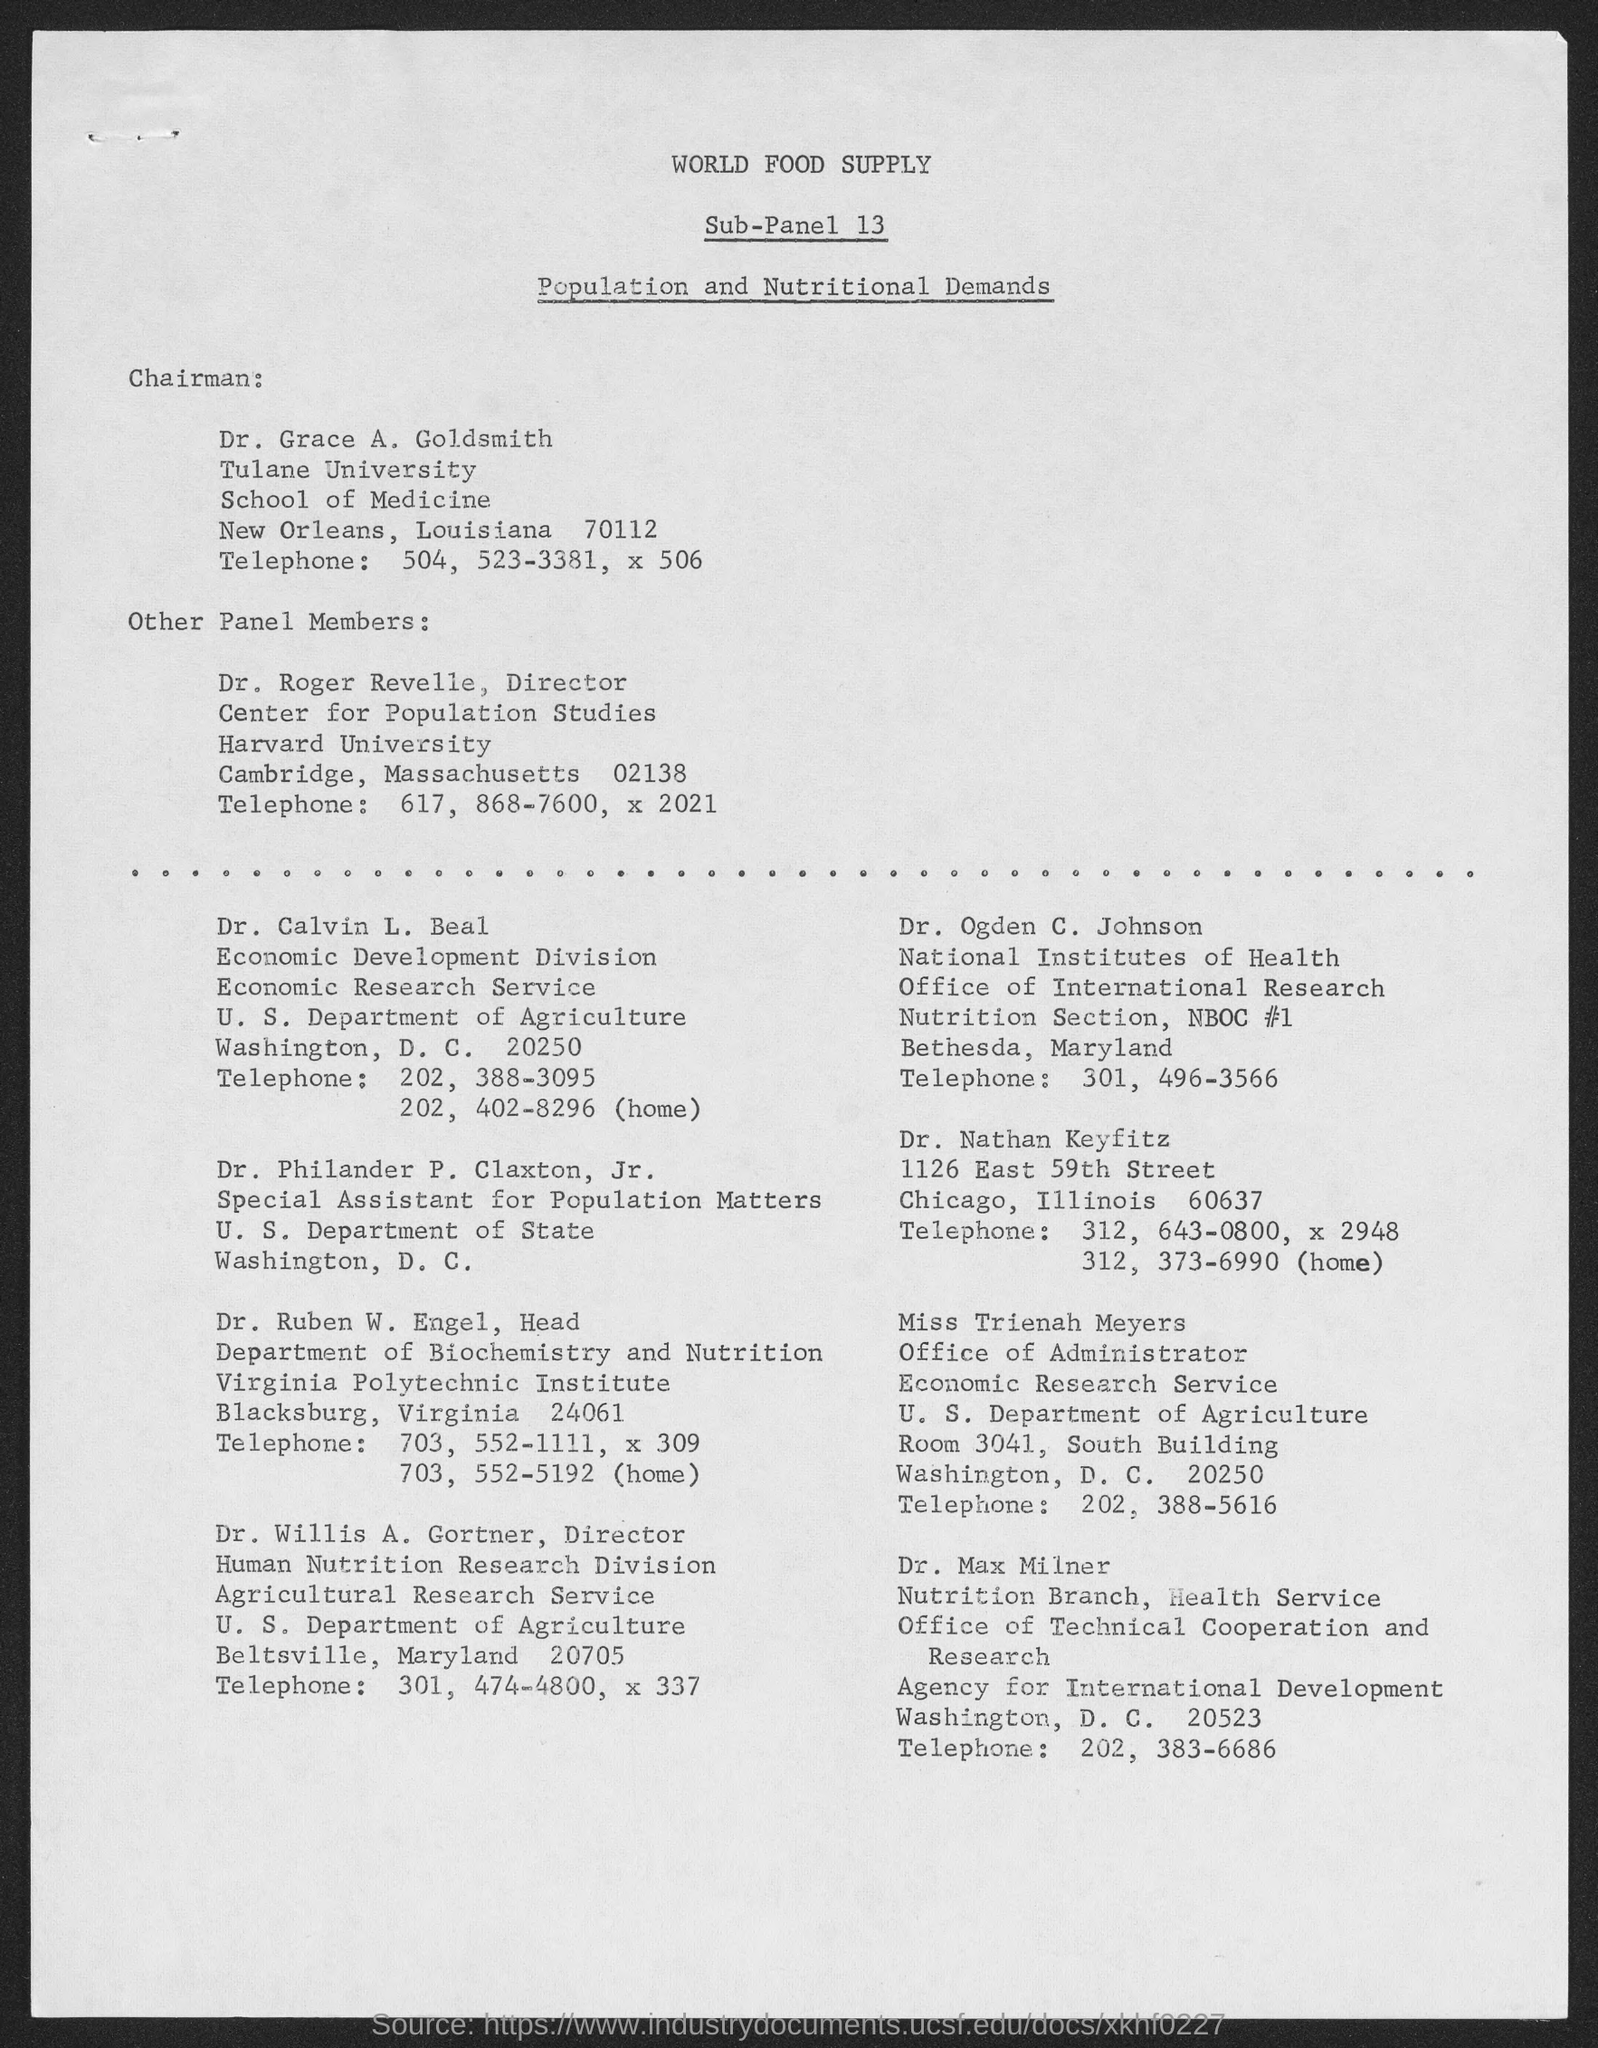List a handful of essential elements in this visual. The Chairman is Dr. Grace A. Goldsmith. 